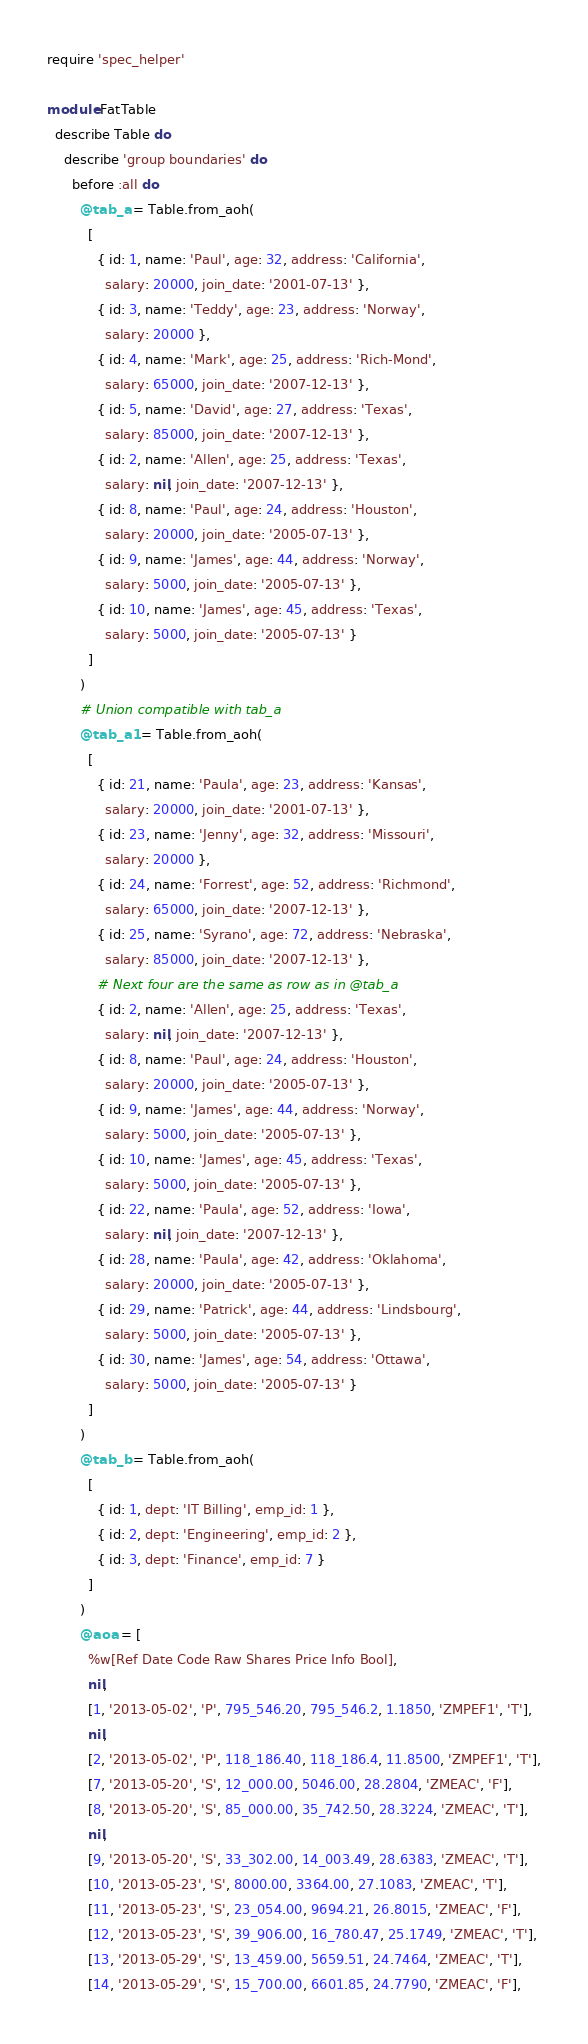Convert code to text. <code><loc_0><loc_0><loc_500><loc_500><_Ruby_>require 'spec_helper'

module FatTable
  describe Table do
    describe 'group boundaries' do
      before :all do
        @tab_a = Table.from_aoh(
          [
            { id: 1, name: 'Paul', age: 32, address: 'California',
              salary: 20000, join_date: '2001-07-13' },
            { id: 3, name: 'Teddy', age: 23, address: 'Norway',
              salary: 20000 },
            { id: 4, name: 'Mark', age: 25, address: 'Rich-Mond',
              salary: 65000, join_date: '2007-12-13' },
            { id: 5, name: 'David', age: 27, address: 'Texas',
              salary: 85000, join_date: '2007-12-13' },
            { id: 2, name: 'Allen', age: 25, address: 'Texas',
              salary: nil, join_date: '2007-12-13' },
            { id: 8, name: 'Paul', age: 24, address: 'Houston',
              salary: 20000, join_date: '2005-07-13' },
            { id: 9, name: 'James', age: 44, address: 'Norway',
              salary: 5000, join_date: '2005-07-13' },
            { id: 10, name: 'James', age: 45, address: 'Texas',
              salary: 5000, join_date: '2005-07-13' }
          ]
        )
        # Union compatible with tab_a
        @tab_a1 = Table.from_aoh(
          [
            { id: 21, name: 'Paula', age: 23, address: 'Kansas',
              salary: 20000, join_date: '2001-07-13' },
            { id: 23, name: 'Jenny', age: 32, address: 'Missouri',
              salary: 20000 },
            { id: 24, name: 'Forrest', age: 52, address: 'Richmond',
              salary: 65000, join_date: '2007-12-13' },
            { id: 25, name: 'Syrano', age: 72, address: 'Nebraska',
              salary: 85000, join_date: '2007-12-13' },
            # Next four are the same as row as in @tab_a
            { id: 2, name: 'Allen', age: 25, address: 'Texas',
              salary: nil, join_date: '2007-12-13' },
            { id: 8, name: 'Paul', age: 24, address: 'Houston',
              salary: 20000, join_date: '2005-07-13' },
            { id: 9, name: 'James', age: 44, address: 'Norway',
              salary: 5000, join_date: '2005-07-13' },
            { id: 10, name: 'James', age: 45, address: 'Texas',
              salary: 5000, join_date: '2005-07-13' },
            { id: 22, name: 'Paula', age: 52, address: 'Iowa',
              salary: nil, join_date: '2007-12-13' },
            { id: 28, name: 'Paula', age: 42, address: 'Oklahoma',
              salary: 20000, join_date: '2005-07-13' },
            { id: 29, name: 'Patrick', age: 44, address: 'Lindsbourg',
              salary: 5000, join_date: '2005-07-13' },
            { id: 30, name: 'James', age: 54, address: 'Ottawa',
              salary: 5000, join_date: '2005-07-13' }
          ]
        )
        @tab_b = Table.from_aoh(
          [
            { id: 1, dept: 'IT Billing', emp_id: 1 },
            { id: 2, dept: 'Engineering', emp_id: 2 },
            { id: 3, dept: 'Finance', emp_id: 7 }
          ]
        )
        @aoa = [
          %w[Ref Date Code Raw Shares Price Info Bool],
          nil,
          [1, '2013-05-02', 'P', 795_546.20, 795_546.2, 1.1850, 'ZMPEF1', 'T'],
          nil,
          [2, '2013-05-02', 'P', 118_186.40, 118_186.4, 11.8500, 'ZMPEF1', 'T'],
          [7, '2013-05-20', 'S', 12_000.00, 5046.00, 28.2804, 'ZMEAC', 'F'],
          [8, '2013-05-20', 'S', 85_000.00, 35_742.50, 28.3224, 'ZMEAC', 'T'],
          nil,
          [9, '2013-05-20', 'S', 33_302.00, 14_003.49, 28.6383, 'ZMEAC', 'T'],
          [10, '2013-05-23', 'S', 8000.00, 3364.00, 27.1083, 'ZMEAC', 'T'],
          [11, '2013-05-23', 'S', 23_054.00, 9694.21, 26.8015, 'ZMEAC', 'F'],
          [12, '2013-05-23', 'S', 39_906.00, 16_780.47, 25.1749, 'ZMEAC', 'T'],
          [13, '2013-05-29', 'S', 13_459.00, 5659.51, 24.7464, 'ZMEAC', 'T'],
          [14, '2013-05-29', 'S', 15_700.00, 6601.85, 24.7790, 'ZMEAC', 'F'],</code> 